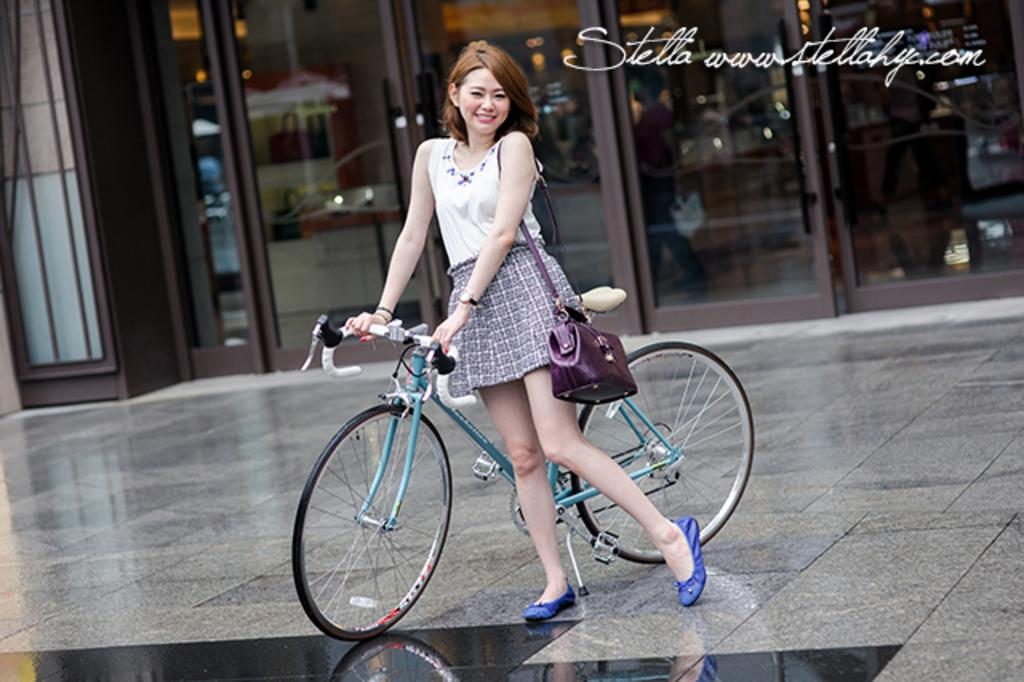Who is present in the image? There is a woman in the image. What is the woman doing in the image? The woman is standing on the floor and holding a bicycle. What type of windows can be seen in the image? There are glass windows visible in the image. What can be seen in the background of the image? There are lights and people standing in the background of the image. What type of building is depicted in the image? There is no building present in the image; it features a woman holding a bicycle. How many people are acting in a crowd in the image? There is no crowd or act present in the image; it features a woman holding a bicycle and people standing in the background. 